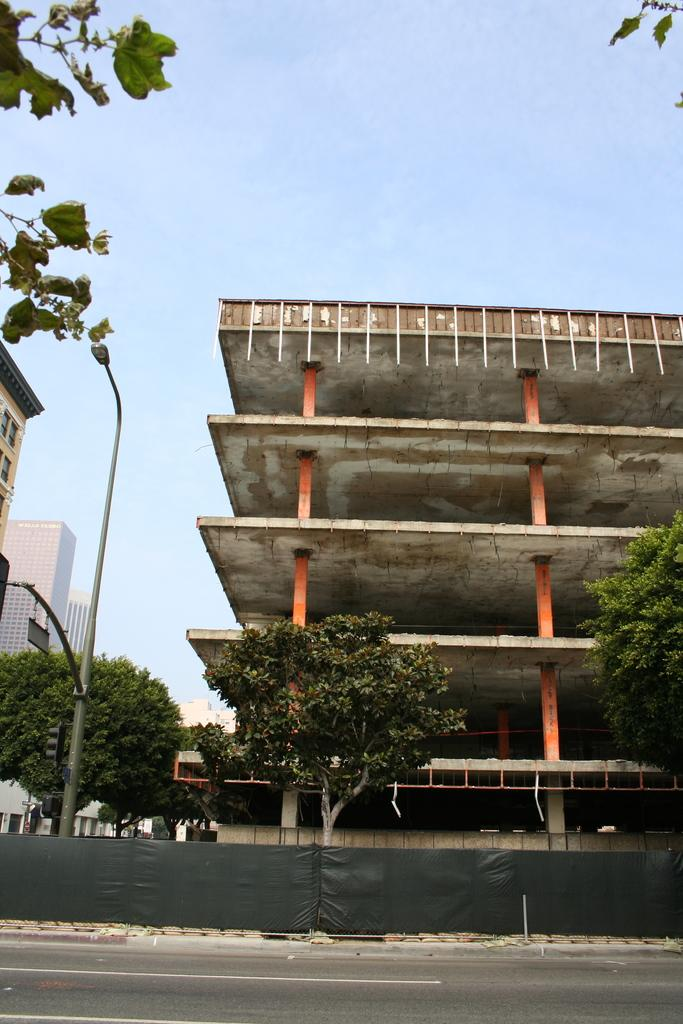What type of living organisms can be seen in the image? Plants can be seen in the image. What color are the plants in the image? The plants are green. What is the tall, vertical structure in the image? There is a light pole in the image. What type of structures can be seen in the background of the image? Buildings can be seen in the background of the image. What colors are the buildings in the image? The buildings are in cream and white colors. What color is the sky in the image? The sky is blue. How many screws can be seen holding the plants in the image? There are no screws visible in the image; the plants are not attached to any structure. What type of hot beverage is being served in the image? There is no hot beverage present in the image. 